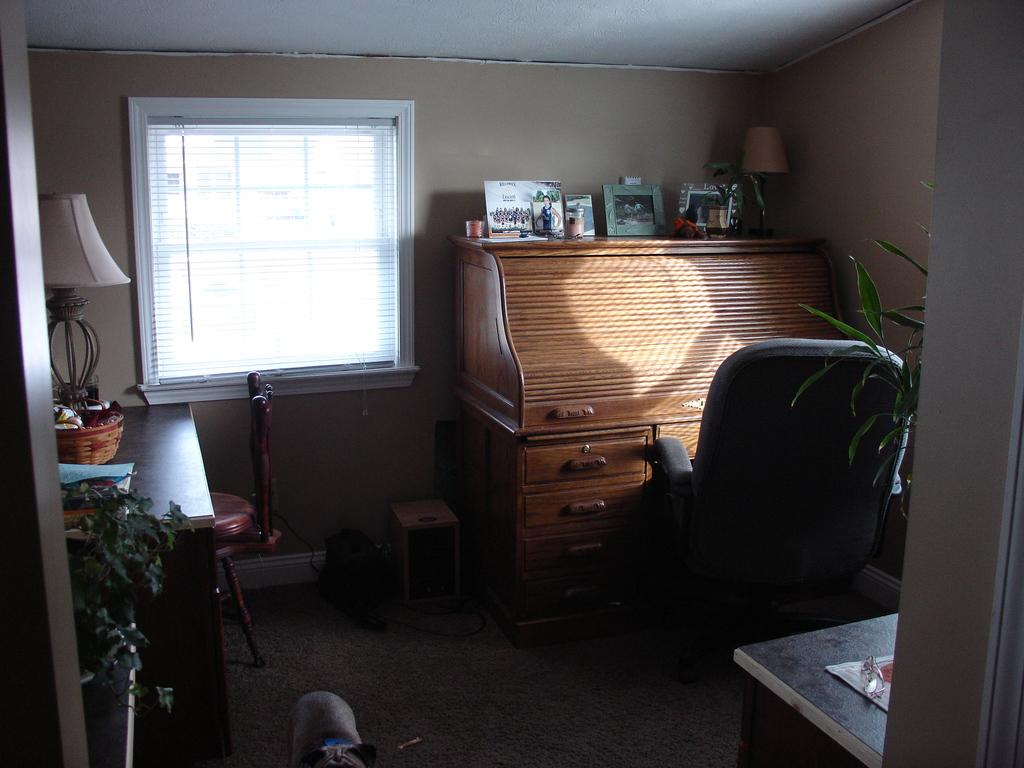What type of furniture is present in the image? There is a chair and a cupboard in the image. What is on the cupboard? There are frames on the cupboard. What else can be seen in the image besides furniture? There are plants and lamps in the image. How many pancakes are stacked on the chair in the image? There are no pancakes present in the image. What type of fish can be seen swimming in the cupboard? There are no fish present in the image. 